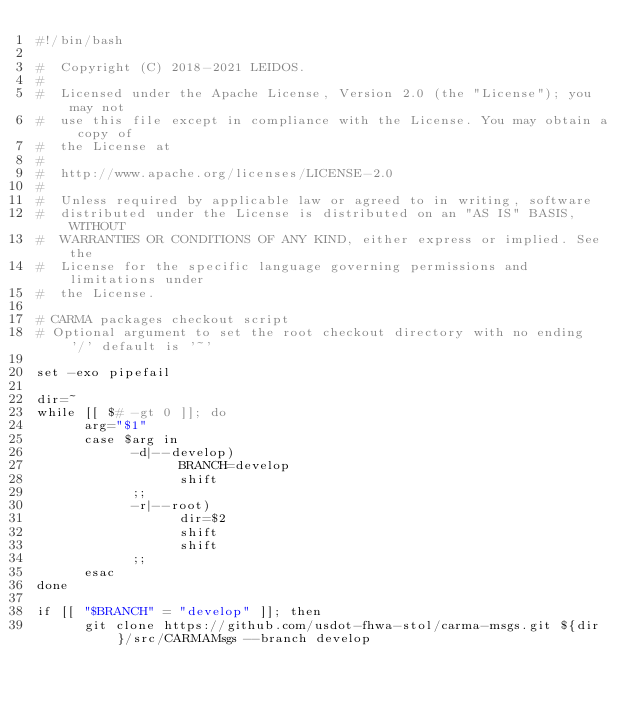<code> <loc_0><loc_0><loc_500><loc_500><_Bash_>#!/bin/bash

#  Copyright (C) 2018-2021 LEIDOS.
# 
#  Licensed under the Apache License, Version 2.0 (the "License"); you may not
#  use this file except in compliance with the License. You may obtain a copy of
#  the License at
# 
#  http://www.apache.org/licenses/LICENSE-2.0
# 
#  Unless required by applicable law or agreed to in writing, software
#  distributed under the License is distributed on an "AS IS" BASIS, WITHOUT
#  WARRANTIES OR CONDITIONS OF ANY KIND, either express or implied. See the
#  License for the specific language governing permissions and limitations under
#  the License.

# CARMA packages checkout script
# Optional argument to set the root checkout directory with no ending '/' default is '~'

set -exo pipefail

dir=~
while [[ $# -gt 0 ]]; do
      arg="$1"
      case $arg in
            -d|--develop)
                  BRANCH=develop
                  shift
            ;;
            -r|--root)
                  dir=$2
                  shift
                  shift
            ;;
      esac
done

if [[ "$BRANCH" = "develop" ]]; then
      git clone https://github.com/usdot-fhwa-stol/carma-msgs.git ${dir}/src/CARMAMsgs --branch develop</code> 